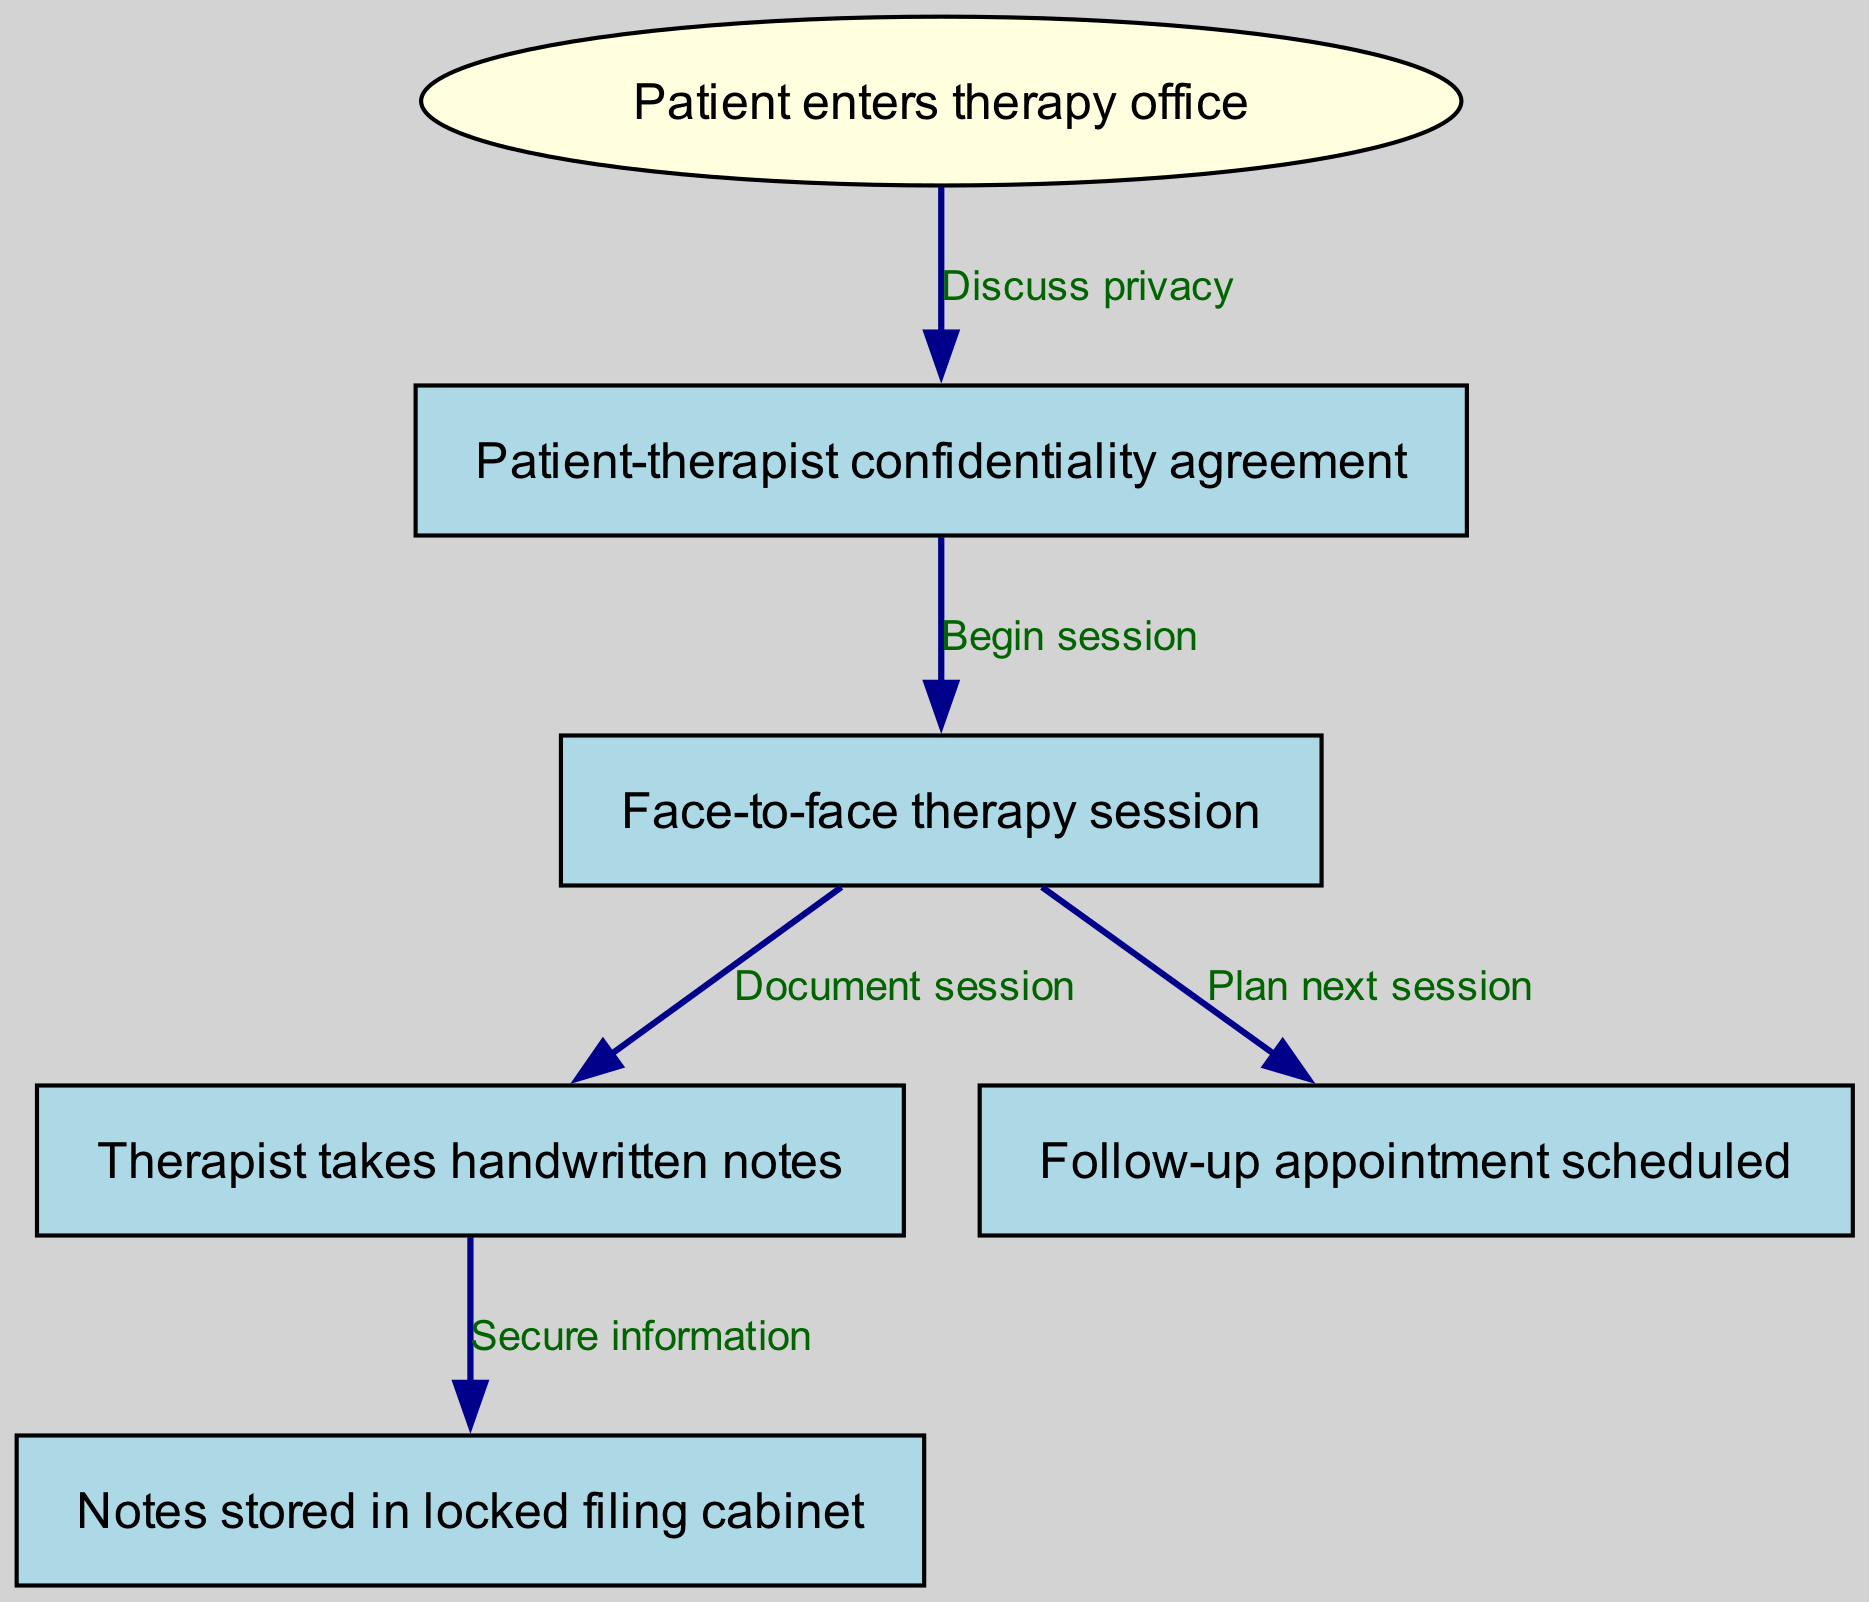What is the starting node of the flow chart? The flow chart begins with the node titled "Patient enters therapy office." This is the first point in the graphical representation where the process initiates.
Answer: Patient enters therapy office How many nodes are in the diagram? The diagram contains a total of six nodes: one starting node and five additional nodes that represent various stages in the therapy process.
Answer: 6 What is the label on the edge from "Patient-therapist confidentiality agreement" to "Face-to-face therapy session"? The edge connecting these two nodes is labeled "Begin session," indicating the transition from establishing confidentiality to starting the therapy session.
Answer: Begin session Which node directly follows "Therapist takes handwritten notes"? The node that directly follows "Therapist takes handwritten notes" is "Notes stored in locked filing cabinet," showing that the documentation process leads to securing the notes.
Answer: Notes stored in locked filing cabinet What does the last node represent in the therapy flow? The last node in the flow chart is titled "Follow-up appointment scheduled," indicating the conclusion of the current session and planning for future sessions to continue the therapy process.
Answer: Follow-up appointment scheduled Which node is the result of the "Face-to-face therapy session"? The "Face-to-face therapy session" leads to two outcomes: "Therapist takes handwritten notes" and "Follow-up appointment scheduled." Therefore, both nodes can be considered results of the session.
Answer: Therapist takes handwritten notes, Follow-up appointment scheduled What is the relationship between "Patient enters therapy office" and "Patient-therapist confidentiality agreement"? The relationship is indicated by the edge labeled "Discuss privacy," which signifies that a discussion regarding privacy takes place before any agreements are made.
Answer: Discuss privacy How is the information from the therapy session secured after notes are taken? The information is secured by storing the handwritten notes in a "locked filing cabinet," which serves as a physical means of protecting the confidentiality of the therapy records.
Answer: Notes stored in locked filing cabinet What is the purpose of the "Patient-therapist confidentiality agreement"? The purpose is to establish trust and clarify the limits of confidentiality before beginning therapy, ensuring that the patient understands their privacy rights.
Answer: Establish trust 